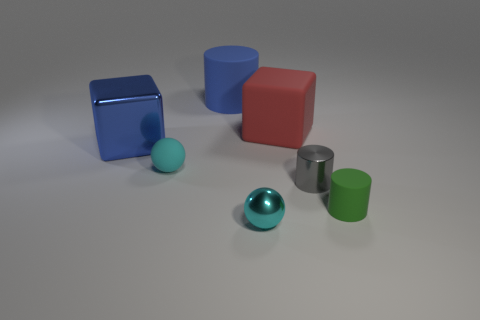Add 3 green things. How many objects exist? 10 Subtract all cylinders. How many objects are left? 4 Subtract all big rubber blocks. Subtract all large cubes. How many objects are left? 4 Add 1 big things. How many big things are left? 4 Add 7 large brown balls. How many large brown balls exist? 7 Subtract 1 gray cylinders. How many objects are left? 6 